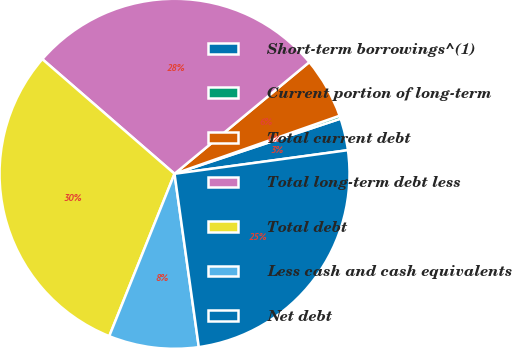Convert chart to OTSL. <chart><loc_0><loc_0><loc_500><loc_500><pie_chart><fcel>Short-term borrowings^(1)<fcel>Current portion of long-term<fcel>Total current debt<fcel>Total long-term debt less<fcel>Total debt<fcel>Less cash and cash equivalents<fcel>Net debt<nl><fcel>2.95%<fcel>0.28%<fcel>5.63%<fcel>27.62%<fcel>30.29%<fcel>8.3%<fcel>24.94%<nl></chart> 